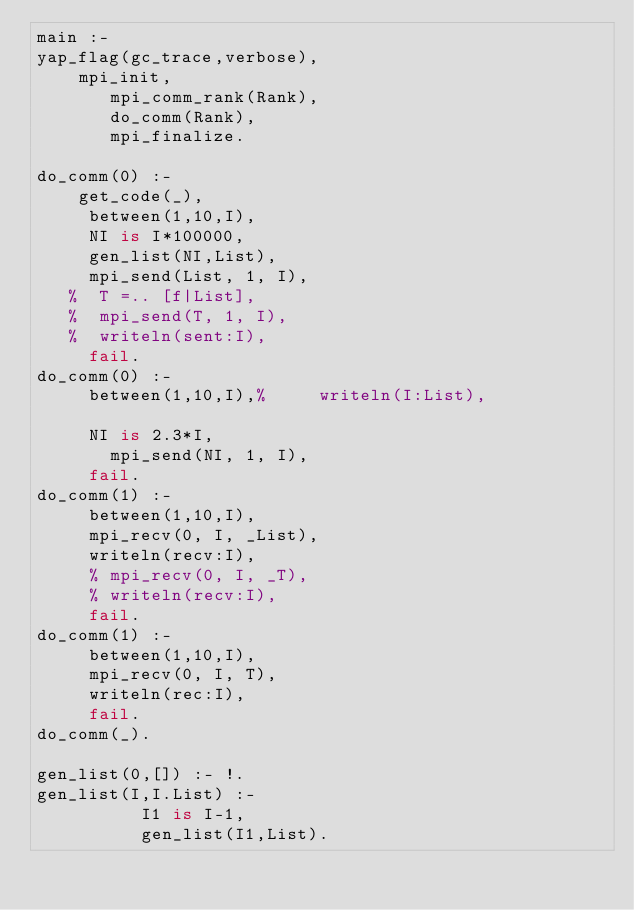Convert code to text. <code><loc_0><loc_0><loc_500><loc_500><_Prolog_>main :-
yap_flag(gc_trace,verbose),
    mpi_init,
       mpi_comm_rank(Rank),
       do_comm(Rank),
       mpi_finalize.

do_comm(0) :-
    get_code(_),
	   between(1,10,I),
	   NI is I*100000,
	   gen_list(NI,List),
	   mpi_send(List, 1, I),
	 %  T =.. [f|List],
	 %  mpi_send(T, 1, I),
	 %  writeln(sent:I),
	   fail.
do_comm(0) :-
	   between(1,10,I),%	   writeln(I:List),

	   NI is 2.3*I,
		   mpi_send(NI, 1, I),
	   fail.
do_comm(1) :-
	   between(1,10,I),
	   mpi_recv(0, I, _List),
	   writeln(recv:I),
	   % mpi_recv(0, I, _T),
	   % writeln(recv:I),
	   fail.
do_comm(1) :-
	   between(1,10,I),
	   mpi_recv(0, I, T),
	   writeln(rec:I),
	   fail.
do_comm(_).

gen_list(0,[]) :- !.
gen_list(I,I.List) :-
          I1 is I-1,
          gen_list(I1,List).

</code> 